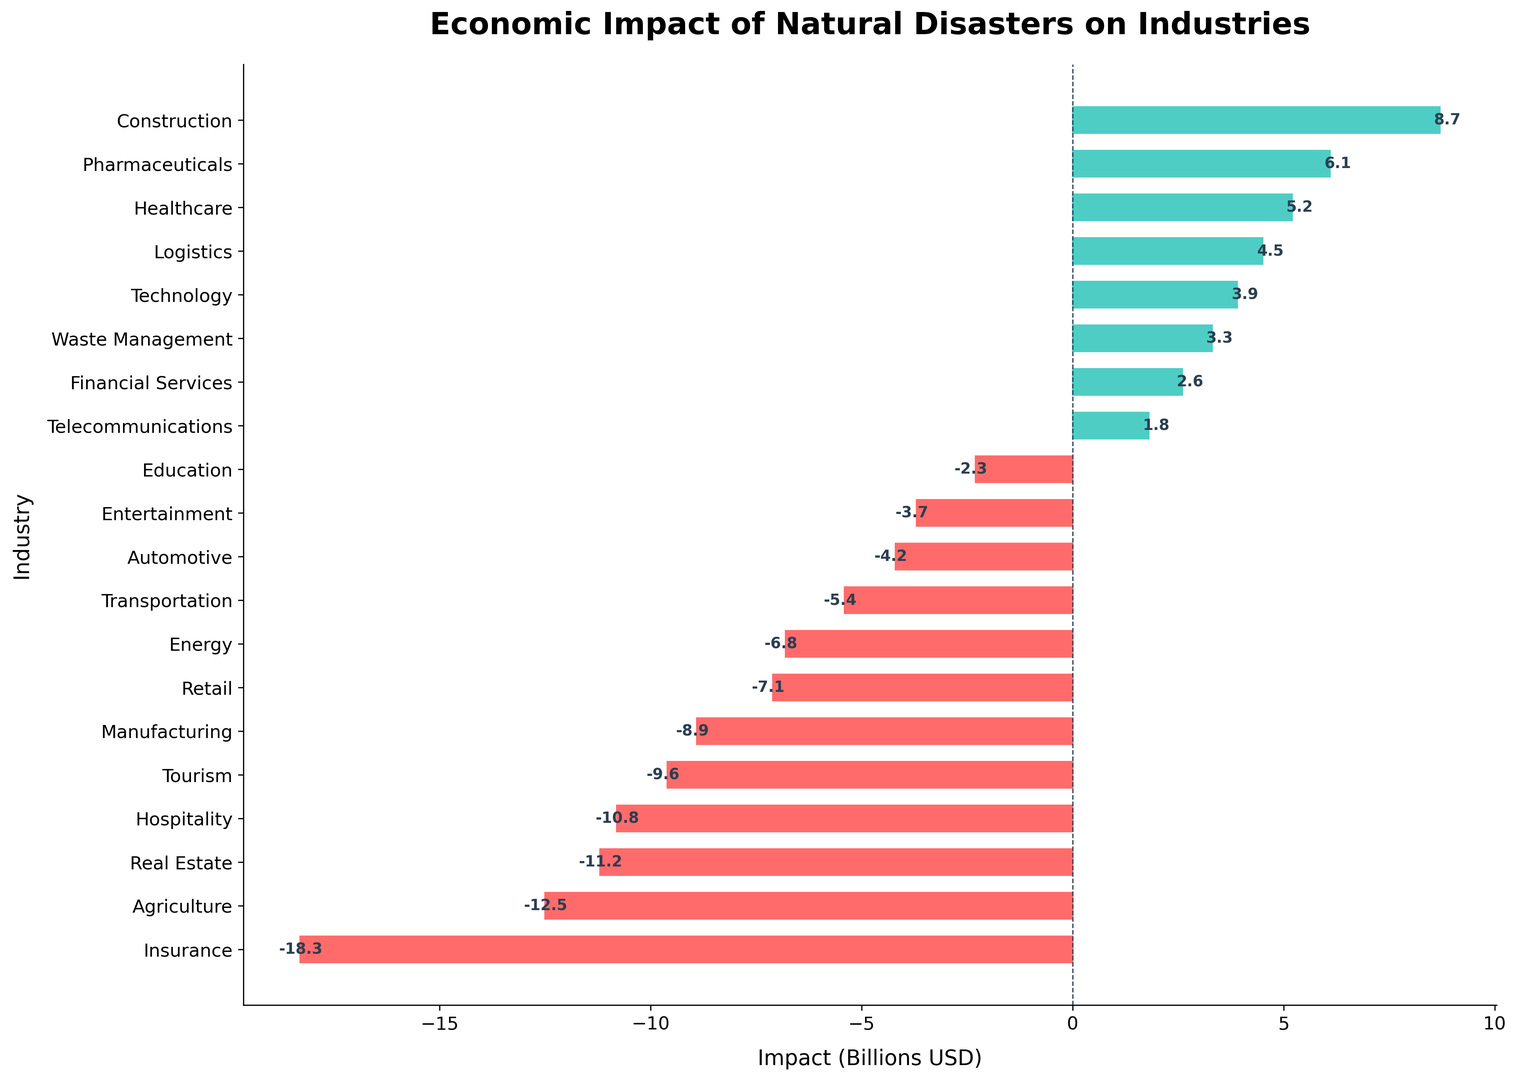Which industry experienced the highest loss? By observing the bar chart, the length of the red bars represents losses. The longest red bar indicates the highest loss, which belongs to the Insurance industry at -18.3 billion USD.
Answer: Insurance Which three industries saw positive impacts of over 5 billion USD? The green bars represent positive impacts. By examining the length of the green bars and reading their labels, we see that Construction (8.7 billion USD), Pharmaceuticals (6.1 billion USD), and Healthcare (5.2 billion USD) all had positive impacts over 5 billion USD.
Answer: Construction, Pharmaceuticals, Healthcare What is the total loss for Agriculture and Real Estate industries combined? To find the total loss, sum the losses of Agriculture (-12.5 billion USD) and Real Estate (-11.2 billion USD). Calculation: -12.5 + (-11.2) = -23.7 billion USD.
Answer: -23.7 billion USD Which industry has the closest positive impact to 4 billion USD? By examining the lengths of the green bars and their labels, the industry with a positive impact closest to 4 billion USD is Technology with 3.9 billion USD.
Answer: Technology How many industries experienced a negative impact? Count the number of red bars, as they represent negative impacts. By counting the red bars, we find that 12 industries experienced negative impacts.
Answer: 12 What is the difference in impact between the Construction and Telecommunications industries? To find the difference, subtract the impact of Telecommunications (1.8 billion USD) from that of Construction (8.7 billion USD). Calculation: 8.7 - 1.8 = 6.9 billion USD.
Answer: 6.9 billion USD Does the Logistics industry have a positive or negative impact, and what is its value? By examining the bars, the Logistics industry has a green bar indicating a positive impact. The value is 4.5 billion USD.
Answer: Positive, 4.5 billion USD What is the average loss among the Healthcare, Financial Services, and Telecommunications industries? The given industries have the following impacts: Healthcare (5.2 billion USD), Financial Services (2.6 billion USD), and Telecommunications (1.8 billion USD). Calculate the average: (5.2 + 2.6 + 1.8) / 3 = 3.2 billion USD.
Answer: 3.2 billion USD Which two industries have the smallest negative impacts, and what are their values? By observing the red bars and their lengths, the two industries with the smallest negative impacts are Education (-2.3 billion USD) and Entertainment (-3.7 billion USD).
Answer: Education, Entertainment What is the net economic impact (total of gains and losses) across all industries? To find the net impact, sum all positive and negative values. Calculation: -12.5 + 8.7 - 18.3 - 9.6 + 5.2 - 7.1 - 6.8 + 3.9 - 5.4 - 11.2 - 8.9 + 2.6 + 1.8 - 2.3 - 3.7 + 4.5 - 4.2 + 6.1 - 10.8 + 3.3 = -60.1 billion USD.
Answer: -60.1 billion USD 